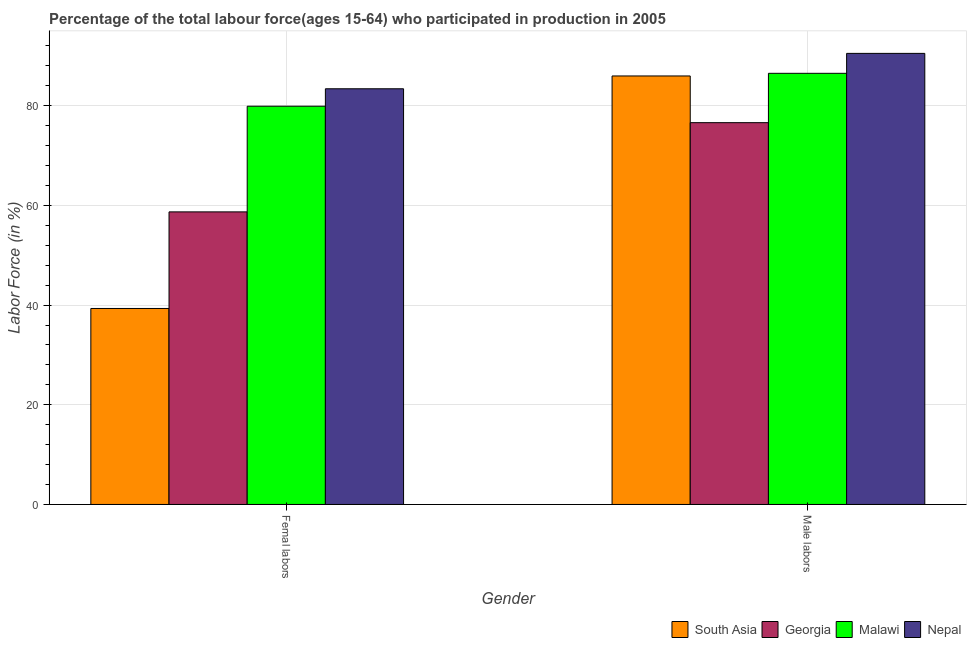How many groups of bars are there?
Provide a succinct answer. 2. Are the number of bars on each tick of the X-axis equal?
Give a very brief answer. Yes. How many bars are there on the 1st tick from the left?
Offer a terse response. 4. What is the label of the 1st group of bars from the left?
Offer a terse response. Femal labors. What is the percentage of female labor force in Malawi?
Provide a short and direct response. 79.9. Across all countries, what is the maximum percentage of male labour force?
Offer a very short reply. 90.5. Across all countries, what is the minimum percentage of female labor force?
Make the answer very short. 39.32. In which country was the percentage of female labor force maximum?
Your response must be concise. Nepal. In which country was the percentage of male labour force minimum?
Make the answer very short. Georgia. What is the total percentage of male labour force in the graph?
Your answer should be very brief. 339.57. What is the difference between the percentage of male labour force in Malawi and that in South Asia?
Offer a very short reply. 0.53. What is the difference between the percentage of male labour force in South Asia and the percentage of female labor force in Malawi?
Offer a terse response. 6.07. What is the average percentage of female labor force per country?
Your response must be concise. 65.33. What is the difference between the percentage of male labour force and percentage of female labor force in Malawi?
Provide a short and direct response. 6.6. In how many countries, is the percentage of female labor force greater than 84 %?
Your response must be concise. 0. What is the ratio of the percentage of male labour force in South Asia to that in Malawi?
Offer a very short reply. 0.99. What does the 2nd bar from the left in Femal labors represents?
Your answer should be very brief. Georgia. What does the 1st bar from the right in Femal labors represents?
Offer a very short reply. Nepal. How many bars are there?
Keep it short and to the point. 8. What is the difference between two consecutive major ticks on the Y-axis?
Keep it short and to the point. 20. Are the values on the major ticks of Y-axis written in scientific E-notation?
Your answer should be compact. No. Does the graph contain grids?
Offer a terse response. Yes. Where does the legend appear in the graph?
Provide a short and direct response. Bottom right. How are the legend labels stacked?
Your answer should be compact. Horizontal. What is the title of the graph?
Provide a succinct answer. Percentage of the total labour force(ages 15-64) who participated in production in 2005. What is the label or title of the X-axis?
Your answer should be very brief. Gender. What is the Labor Force (in %) of South Asia in Femal labors?
Provide a succinct answer. 39.32. What is the Labor Force (in %) of Georgia in Femal labors?
Offer a terse response. 58.7. What is the Labor Force (in %) in Malawi in Femal labors?
Your answer should be very brief. 79.9. What is the Labor Force (in %) in Nepal in Femal labors?
Give a very brief answer. 83.4. What is the Labor Force (in %) in South Asia in Male labors?
Offer a terse response. 85.97. What is the Labor Force (in %) in Georgia in Male labors?
Offer a terse response. 76.6. What is the Labor Force (in %) in Malawi in Male labors?
Ensure brevity in your answer.  86.5. What is the Labor Force (in %) in Nepal in Male labors?
Make the answer very short. 90.5. Across all Gender, what is the maximum Labor Force (in %) of South Asia?
Your response must be concise. 85.97. Across all Gender, what is the maximum Labor Force (in %) of Georgia?
Provide a succinct answer. 76.6. Across all Gender, what is the maximum Labor Force (in %) in Malawi?
Make the answer very short. 86.5. Across all Gender, what is the maximum Labor Force (in %) of Nepal?
Offer a very short reply. 90.5. Across all Gender, what is the minimum Labor Force (in %) of South Asia?
Offer a terse response. 39.32. Across all Gender, what is the minimum Labor Force (in %) of Georgia?
Provide a short and direct response. 58.7. Across all Gender, what is the minimum Labor Force (in %) in Malawi?
Keep it short and to the point. 79.9. Across all Gender, what is the minimum Labor Force (in %) in Nepal?
Offer a very short reply. 83.4. What is the total Labor Force (in %) in South Asia in the graph?
Offer a terse response. 125.29. What is the total Labor Force (in %) in Georgia in the graph?
Offer a very short reply. 135.3. What is the total Labor Force (in %) in Malawi in the graph?
Offer a very short reply. 166.4. What is the total Labor Force (in %) in Nepal in the graph?
Your response must be concise. 173.9. What is the difference between the Labor Force (in %) of South Asia in Femal labors and that in Male labors?
Give a very brief answer. -46.65. What is the difference between the Labor Force (in %) of Georgia in Femal labors and that in Male labors?
Provide a short and direct response. -17.9. What is the difference between the Labor Force (in %) in Nepal in Femal labors and that in Male labors?
Your answer should be compact. -7.1. What is the difference between the Labor Force (in %) of South Asia in Femal labors and the Labor Force (in %) of Georgia in Male labors?
Your response must be concise. -37.28. What is the difference between the Labor Force (in %) in South Asia in Femal labors and the Labor Force (in %) in Malawi in Male labors?
Make the answer very short. -47.18. What is the difference between the Labor Force (in %) in South Asia in Femal labors and the Labor Force (in %) in Nepal in Male labors?
Make the answer very short. -51.18. What is the difference between the Labor Force (in %) of Georgia in Femal labors and the Labor Force (in %) of Malawi in Male labors?
Ensure brevity in your answer.  -27.8. What is the difference between the Labor Force (in %) of Georgia in Femal labors and the Labor Force (in %) of Nepal in Male labors?
Your response must be concise. -31.8. What is the difference between the Labor Force (in %) in Malawi in Femal labors and the Labor Force (in %) in Nepal in Male labors?
Your response must be concise. -10.6. What is the average Labor Force (in %) of South Asia per Gender?
Offer a very short reply. 62.64. What is the average Labor Force (in %) of Georgia per Gender?
Make the answer very short. 67.65. What is the average Labor Force (in %) of Malawi per Gender?
Provide a short and direct response. 83.2. What is the average Labor Force (in %) in Nepal per Gender?
Your response must be concise. 86.95. What is the difference between the Labor Force (in %) of South Asia and Labor Force (in %) of Georgia in Femal labors?
Provide a succinct answer. -19.38. What is the difference between the Labor Force (in %) of South Asia and Labor Force (in %) of Malawi in Femal labors?
Make the answer very short. -40.58. What is the difference between the Labor Force (in %) in South Asia and Labor Force (in %) in Nepal in Femal labors?
Offer a very short reply. -44.08. What is the difference between the Labor Force (in %) of Georgia and Labor Force (in %) of Malawi in Femal labors?
Provide a succinct answer. -21.2. What is the difference between the Labor Force (in %) in Georgia and Labor Force (in %) in Nepal in Femal labors?
Offer a terse response. -24.7. What is the difference between the Labor Force (in %) of South Asia and Labor Force (in %) of Georgia in Male labors?
Offer a terse response. 9.37. What is the difference between the Labor Force (in %) in South Asia and Labor Force (in %) in Malawi in Male labors?
Make the answer very short. -0.53. What is the difference between the Labor Force (in %) of South Asia and Labor Force (in %) of Nepal in Male labors?
Provide a short and direct response. -4.53. What is the difference between the Labor Force (in %) of Georgia and Labor Force (in %) of Malawi in Male labors?
Offer a very short reply. -9.9. What is the difference between the Labor Force (in %) in Georgia and Labor Force (in %) in Nepal in Male labors?
Your response must be concise. -13.9. What is the difference between the Labor Force (in %) in Malawi and Labor Force (in %) in Nepal in Male labors?
Your answer should be very brief. -4. What is the ratio of the Labor Force (in %) of South Asia in Femal labors to that in Male labors?
Your answer should be very brief. 0.46. What is the ratio of the Labor Force (in %) in Georgia in Femal labors to that in Male labors?
Provide a succinct answer. 0.77. What is the ratio of the Labor Force (in %) of Malawi in Femal labors to that in Male labors?
Provide a succinct answer. 0.92. What is the ratio of the Labor Force (in %) of Nepal in Femal labors to that in Male labors?
Make the answer very short. 0.92. What is the difference between the highest and the second highest Labor Force (in %) of South Asia?
Give a very brief answer. 46.65. What is the difference between the highest and the second highest Labor Force (in %) in Malawi?
Your answer should be very brief. 6.6. What is the difference between the highest and the lowest Labor Force (in %) of South Asia?
Give a very brief answer. 46.65. What is the difference between the highest and the lowest Labor Force (in %) in Georgia?
Ensure brevity in your answer.  17.9. 